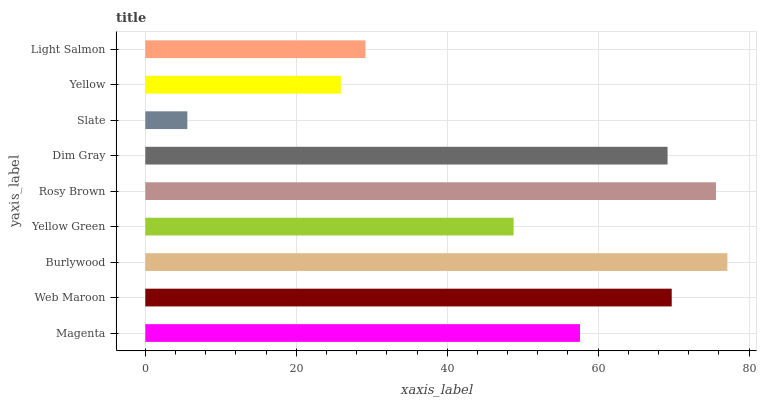Is Slate the minimum?
Answer yes or no. Yes. Is Burlywood the maximum?
Answer yes or no. Yes. Is Web Maroon the minimum?
Answer yes or no. No. Is Web Maroon the maximum?
Answer yes or no. No. Is Web Maroon greater than Magenta?
Answer yes or no. Yes. Is Magenta less than Web Maroon?
Answer yes or no. Yes. Is Magenta greater than Web Maroon?
Answer yes or no. No. Is Web Maroon less than Magenta?
Answer yes or no. No. Is Magenta the high median?
Answer yes or no. Yes. Is Magenta the low median?
Answer yes or no. Yes. Is Dim Gray the high median?
Answer yes or no. No. Is Rosy Brown the low median?
Answer yes or no. No. 